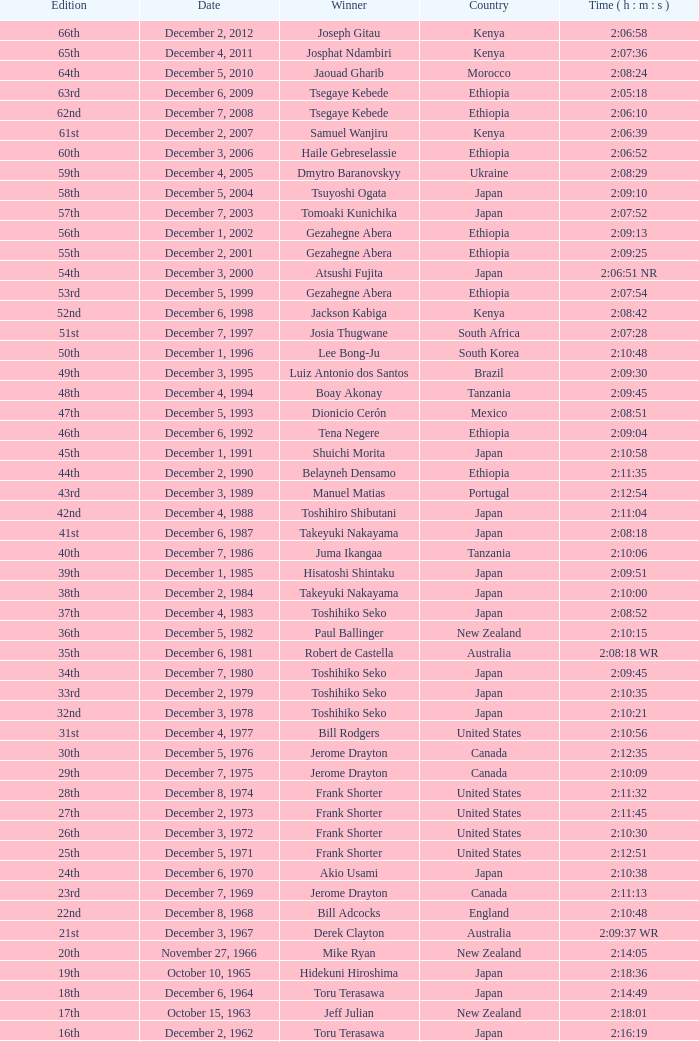On what date was the 48th Edition raced? December 4, 1994. 